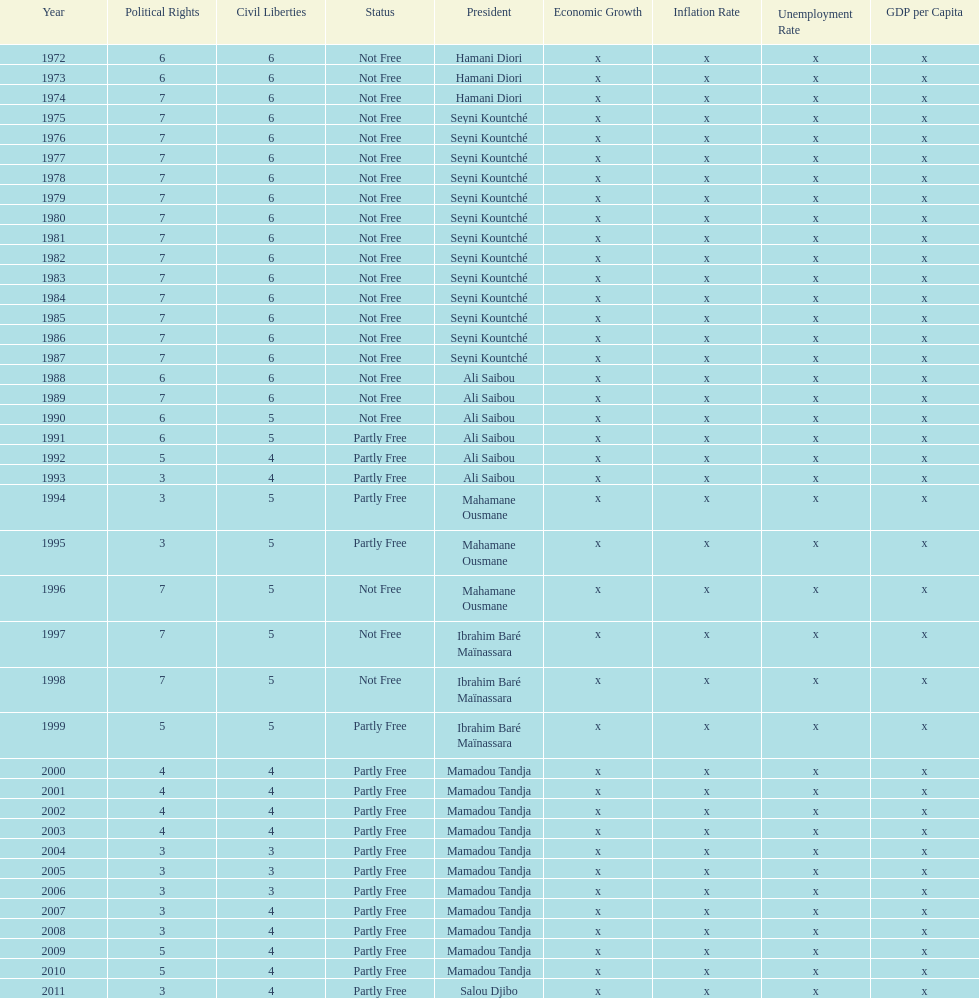Can you give me this table as a dict? {'header': ['Year', 'Political Rights', 'Civil Liberties', 'Status', 'President', 'Economic Growth', 'Inflation Rate', 'Unemployment Rate', 'GDP per Capita'], 'rows': [['1972', '6', '6', 'Not Free', 'Hamani Diori', 'x', 'x', 'x', 'x'], ['1973', '6', '6', 'Not Free', 'Hamani Diori', 'x', 'x', 'x', 'x'], ['1974', '7', '6', 'Not Free', 'Hamani Diori', 'x', 'x', 'x', 'x'], ['1975', '7', '6', 'Not Free', 'Seyni Kountché', 'x', 'x', 'x', 'x'], ['1976', '7', '6', 'Not Free', 'Seyni Kountché', 'x', 'x', 'x', 'x'], ['1977', '7', '6', 'Not Free', 'Seyni Kountché', 'x', 'x', 'x', 'x'], ['1978', '7', '6', 'Not Free', 'Seyni Kountché', 'x', 'x', 'x', 'x'], ['1979', '7', '6', 'Not Free', 'Seyni Kountché', 'x', 'x', 'x', 'x'], ['1980', '7', '6', 'Not Free', 'Seyni Kountché', 'x', 'x', 'x', 'x'], ['1981', '7', '6', 'Not Free', 'Seyni Kountché', 'x', 'x', 'x', 'x'], ['1982', '7', '6', 'Not Free', 'Seyni Kountché', 'x', 'x', 'x', 'x'], ['1983', '7', '6', 'Not Free', 'Seyni Kountché', 'x', 'x', 'x', 'x'], ['1984', '7', '6', 'Not Free', 'Seyni Kountché', 'x', 'x', 'x', 'x'], ['1985', '7', '6', 'Not Free', 'Seyni Kountché', 'x', 'x', 'x', 'x'], ['1986', '7', '6', 'Not Free', 'Seyni Kountché', 'x', 'x', 'x', 'x'], ['1987', '7', '6', 'Not Free', 'Seyni Kountché', 'x', 'x', 'x', 'x'], ['1988', '6', '6', 'Not Free', 'Ali Saibou', 'x', 'x', 'x', 'x'], ['1989', '7', '6', 'Not Free', 'Ali Saibou', 'x', 'x', 'x', 'x'], ['1990', '6', '5', 'Not Free', 'Ali Saibou', 'x', 'x', 'x', 'x'], ['1991', '6', '5', 'Partly Free', 'Ali Saibou', 'x', 'x', 'x', 'x'], ['1992', '5', '4', 'Partly Free', 'Ali Saibou', 'x', 'x', 'x', 'x'], ['1993', '3', '4', 'Partly Free', 'Ali Saibou', 'x', 'x', 'x', 'x'], ['1994', '3', '5', 'Partly Free', 'Mahamane Ousmane', 'x', 'x', 'x', 'x'], ['1995', '3', '5', 'Partly Free', 'Mahamane Ousmane', 'x', 'x', 'x', 'x'], ['1996', '7', '5', 'Not Free', 'Mahamane Ousmane', 'x', 'x', 'x', 'x'], ['1997', '7', '5', 'Not Free', 'Ibrahim Baré Maïnassara', 'x', 'x', 'x', 'x'], ['1998', '7', '5', 'Not Free', 'Ibrahim Baré Maïnassara', 'x', 'x', 'x', 'x'], ['1999', '5', '5', 'Partly Free', 'Ibrahim Baré Maïnassara', 'x', 'x', 'x', 'x'], ['2000', '4', '4', 'Partly Free', 'Mamadou Tandja', 'x', 'x', 'x', 'x'], ['2001', '4', '4', 'Partly Free', 'Mamadou Tandja', 'x', 'x', 'x', 'x'], ['2002', '4', '4', 'Partly Free', 'Mamadou Tandja', 'x', 'x', 'x', 'x'], ['2003', '4', '4', 'Partly Free', 'Mamadou Tandja', 'x', 'x', 'x', 'x'], ['2004', '3', '3', 'Partly Free', 'Mamadou Tandja', 'x', 'x', 'x', 'x'], ['2005', '3', '3', 'Partly Free', 'Mamadou Tandja', 'x', 'x', 'x', 'x'], ['2006', '3', '3', 'Partly Free', 'Mamadou Tandja', 'x', 'x', 'x', 'x'], ['2007', '3', '4', 'Partly Free', 'Mamadou Tandja', 'x', 'x', 'x', 'x'], ['2008', '3', '4', 'Partly Free', 'Mamadou Tandja', 'x', 'x', 'x', 'x'], ['2009', '5', '4', 'Partly Free', 'Mamadou Tandja', 'x', 'x', 'x', 'x'], ['2010', '5', '4', 'Partly Free', 'Mamadou Tandja', 'x', 'x', 'x', 'x'], ['2011', '3', '4', 'Partly Free', 'Salou Djibo', 'x', 'x', 'x', 'x']]} How long did it take for civil liberties to decrease below 6? 18 years. 